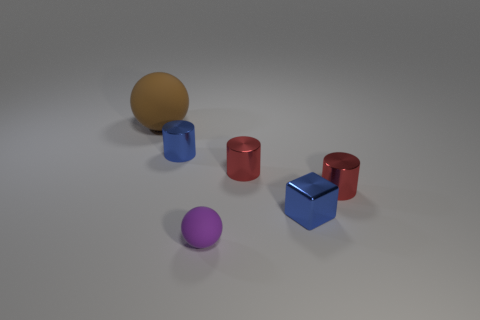Add 4 big blue metallic blocks. How many objects exist? 10 Subtract all spheres. How many objects are left? 4 Subtract all tiny cyan matte blocks. Subtract all brown rubber spheres. How many objects are left? 5 Add 3 matte objects. How many matte objects are left? 5 Add 2 blue blocks. How many blue blocks exist? 3 Subtract 0 gray spheres. How many objects are left? 6 